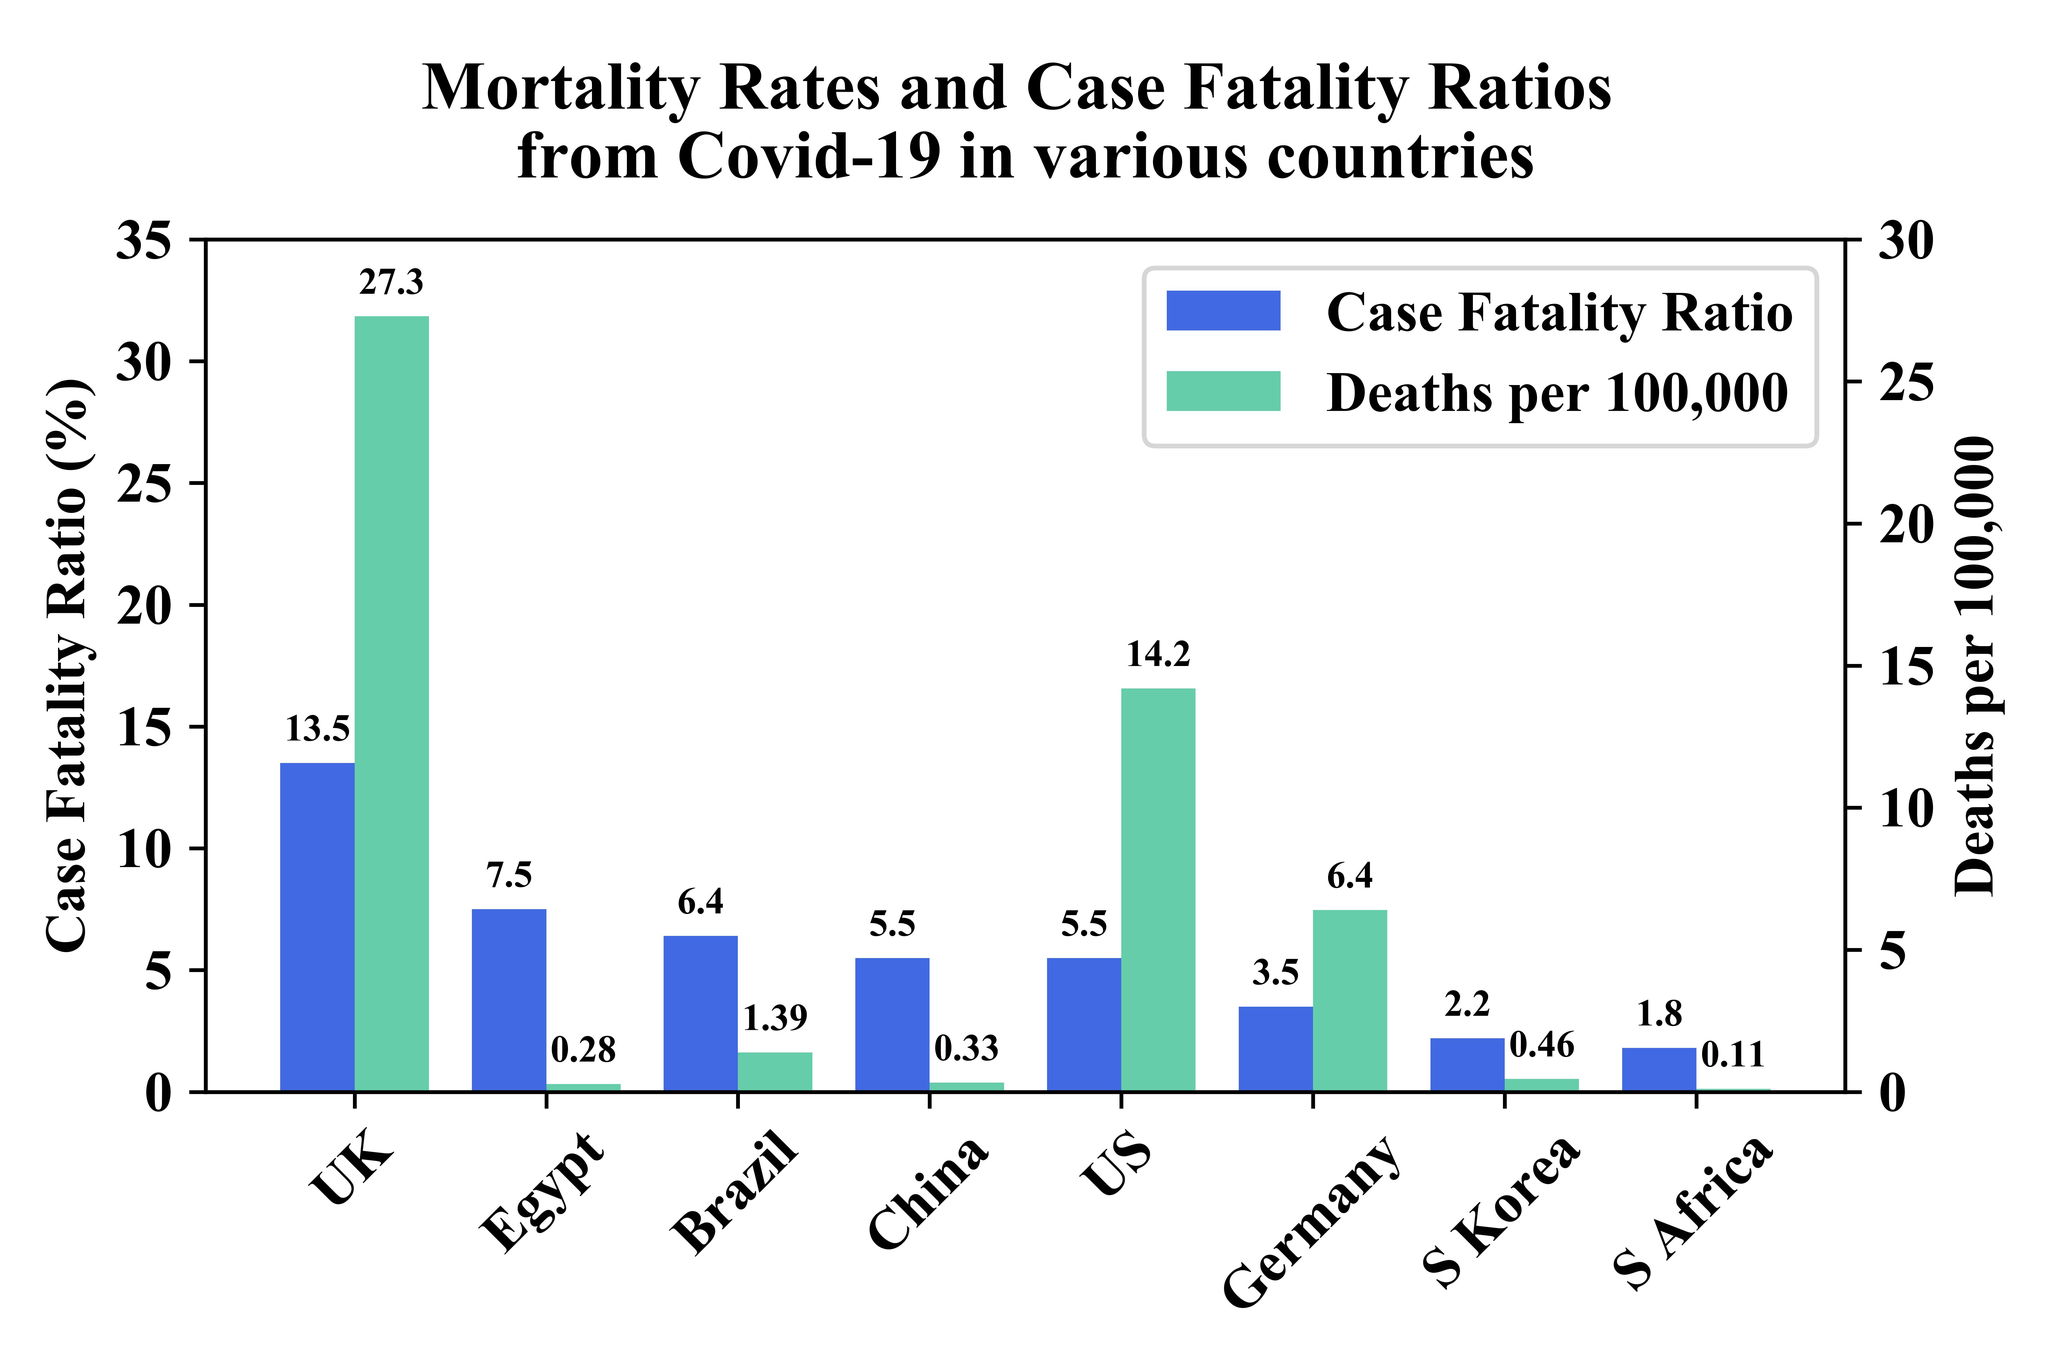List a handful of essential elements in this visual. There are 8 countries represented in this graph. The case fatality ratio in Egypt and Brazil, taken together, is 13.9%. In the UK and the US, taken together, the case fatality ratio is 19%. 